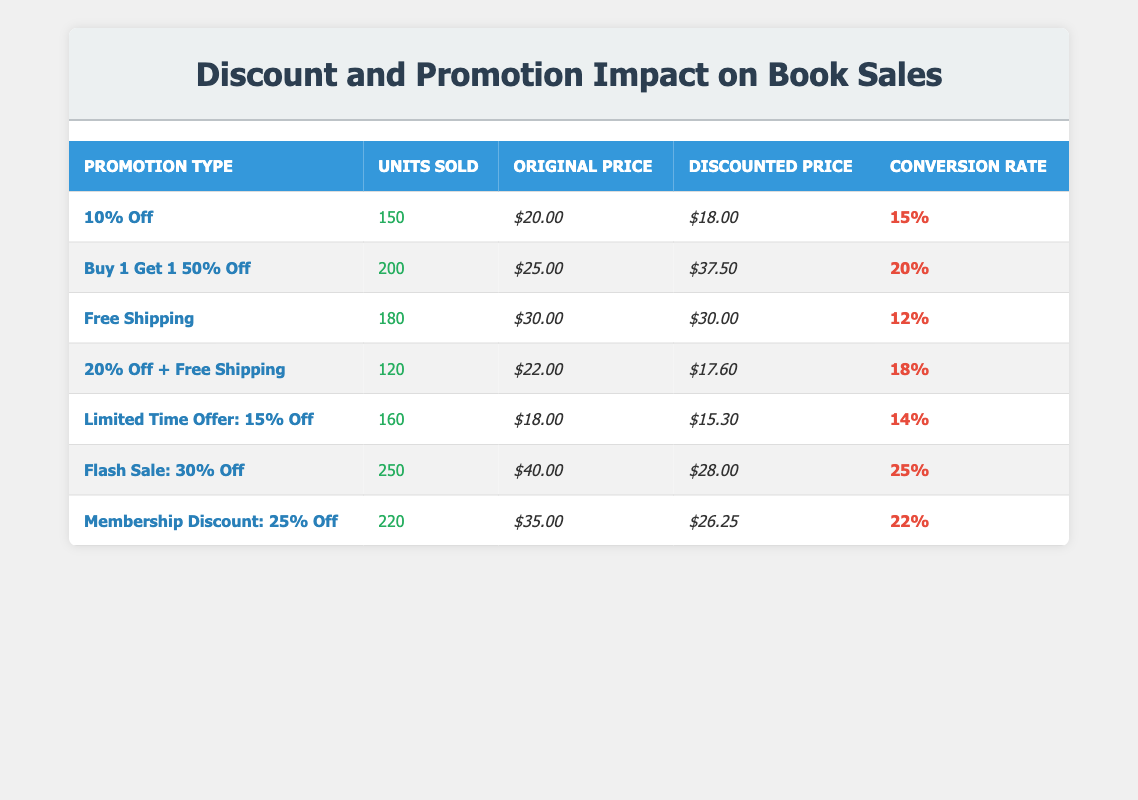What is the conversion rate for the "Flash Sale: 30% Off" promotion? The conversion rate for the "Flash Sale: 30% Off" promotion is listed directly in the table under the corresponding promotion type, which shows a value of 25%.
Answer: 25% How many units were sold under the "Buy 1 Get 1 50% Off" promotion? The number of units sold under the "Buy 1 Get 1 50% Off" promotion can be found in the "Units Sold" column for that promotion type, which is 200.
Answer: 200 What is the discounted price for books under the "20% Off + Free Shipping" promotion? The discounted price for the "20% Off + Free Shipping" promotion is noted in the "Discounted Price" column, which states that the price is $17.60.
Answer: $17.60 Which promotion type had the highest conversion rate? To identify the highest conversion rate, compare all the conversion rates in the "Conversion Rate" column. The "Flash Sale: 30% Off" promotion has the highest rate at 25%.
Answer: Flash Sale: 30% Off What is the average discounted price of all promotions? First, we sum the discounted prices: $18.00 + $37.50 + $30.00 + $17.60 + $15.30 + $28.00 + $26.25 = $172.65. Then, since there are 7 promotions, we divide the total by 7, which results in an average of $24.66.
Answer: $24.66 Is the "Free Shipping" promotion more effective than the "Limited Time Offer: 15% Off" promotion based on their conversion rates? The "Free Shipping" promotion has a conversion rate of 12%, while the "Limited Time Offer: 15% Off" has a conversion rate of 14%. Since 14% is greater than 12%, we can conclude that the "Limited Time Offer: 15% Off" is more effective than the "Free Shipping" promotion.
Answer: No How many units sold were generated from promotions with a conversion rate of 20% or higher? We look for promotions with conversion rates of 20% or higher: "Buy 1 Get 1 50% Off" (200 units), "Flash Sale: 30% Off" (250 units), and "Membership Discount: 25% Off" (220 units). Adding these together gives 200 + 250 + 220 = 670 units sold overall.
Answer: 670 What is the total revenue generated from units sold under the "10% Off" promotion? We calculate the revenue by multiplying the units sold by the discounted price: 150 units * $18.00 = $2700. This shows the total revenue generated from that promotion.
Answer: $2700 Which discount promotion resulted in the lowest number of units sold? By examining the "Units Sold" column, we find that the "20% Off + Free Shipping" promotion produced the lowest sales, at 120 units sold.
Answer: 20% Off + Free Shipping 